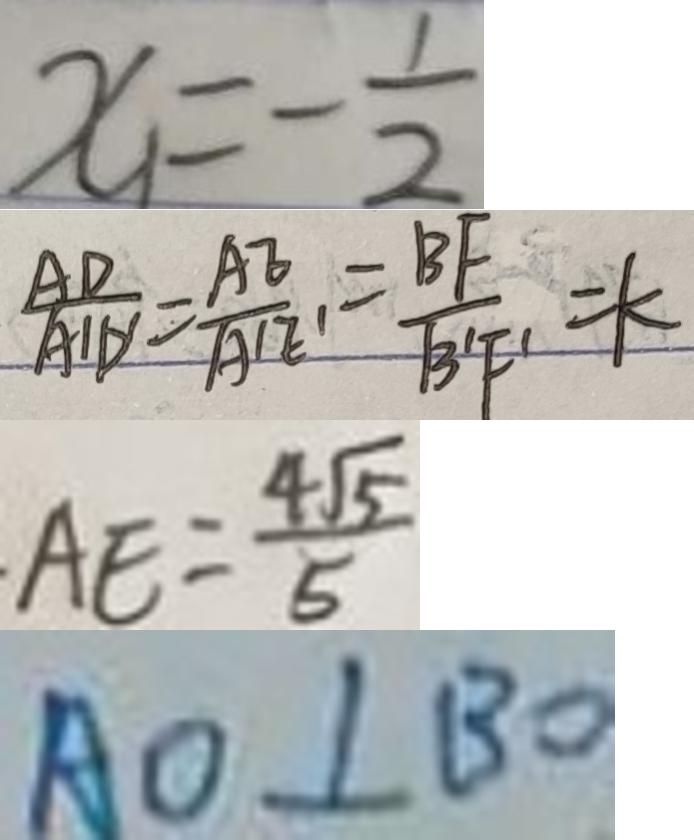Convert formula to latex. <formula><loc_0><loc_0><loc_500><loc_500>x _ { 1 } = - \frac { 1 } { 2 } 
 \frac { A D } { A ^ { \prime } D ^ { \prime } } = \frac { A E } { A ^ { \prime } E ^ { \prime } } = \frac { B F } { B ^ { \prime } F ^ { \prime } } = k 
 \cdot A E = \frac { 4 \sqrt { 5 } } { 5 } 
 A O \bot B O</formula> 